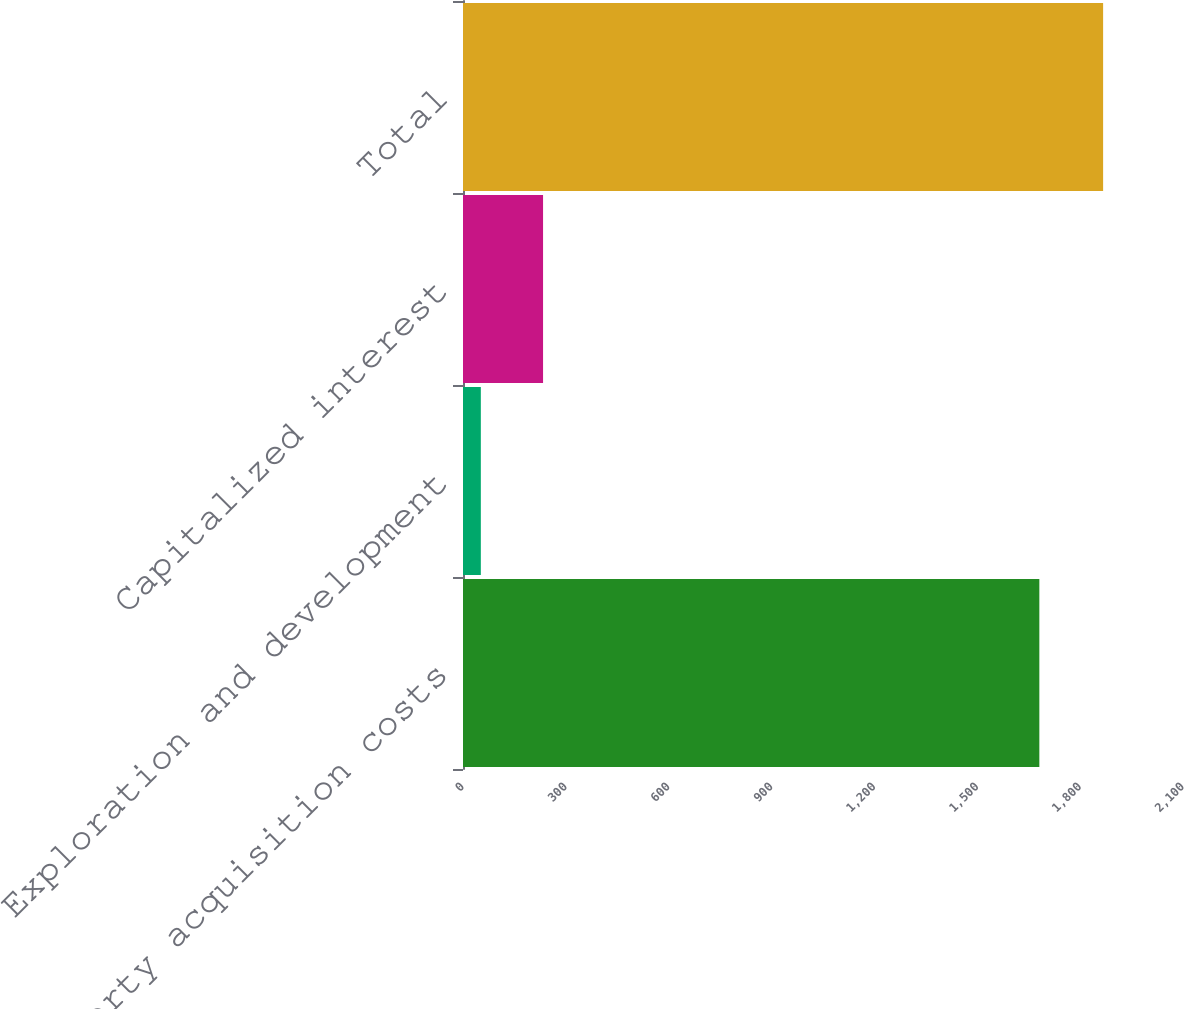<chart> <loc_0><loc_0><loc_500><loc_500><bar_chart><fcel>Property acquisition costs<fcel>Exploration and development<fcel>Capitalized interest<fcel>Total<nl><fcel>1681<fcel>52<fcel>233.5<fcel>1867<nl></chart> 